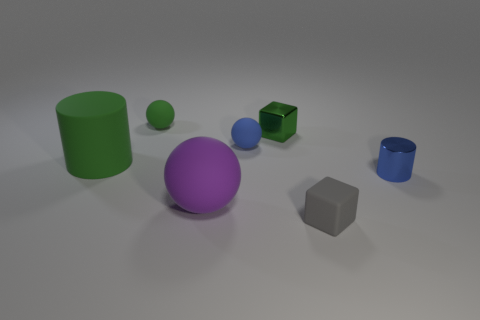What color is the tiny matte ball in front of the green object on the right side of the tiny blue rubber ball?
Ensure brevity in your answer.  Blue. What color is the matte cube that is the same size as the blue matte sphere?
Your answer should be very brief. Gray. What number of rubber objects are on the left side of the small blue rubber object and in front of the small blue shiny cylinder?
Make the answer very short. 1. What is the shape of the thing that is the same color as the tiny cylinder?
Make the answer very short. Sphere. The object that is on the right side of the small green cube and in front of the shiny cylinder is made of what material?
Keep it short and to the point. Rubber. Are there fewer small rubber blocks that are to the left of the small green shiny cube than large objects in front of the big green cylinder?
Your answer should be compact. Yes. What size is the blue ball that is the same material as the small gray cube?
Make the answer very short. Small. Are there any other things of the same color as the large sphere?
Offer a very short reply. No. Do the large green object and the block on the left side of the matte block have the same material?
Your response must be concise. No. What is the material of the other object that is the same shape as the small blue shiny thing?
Offer a terse response. Rubber. 